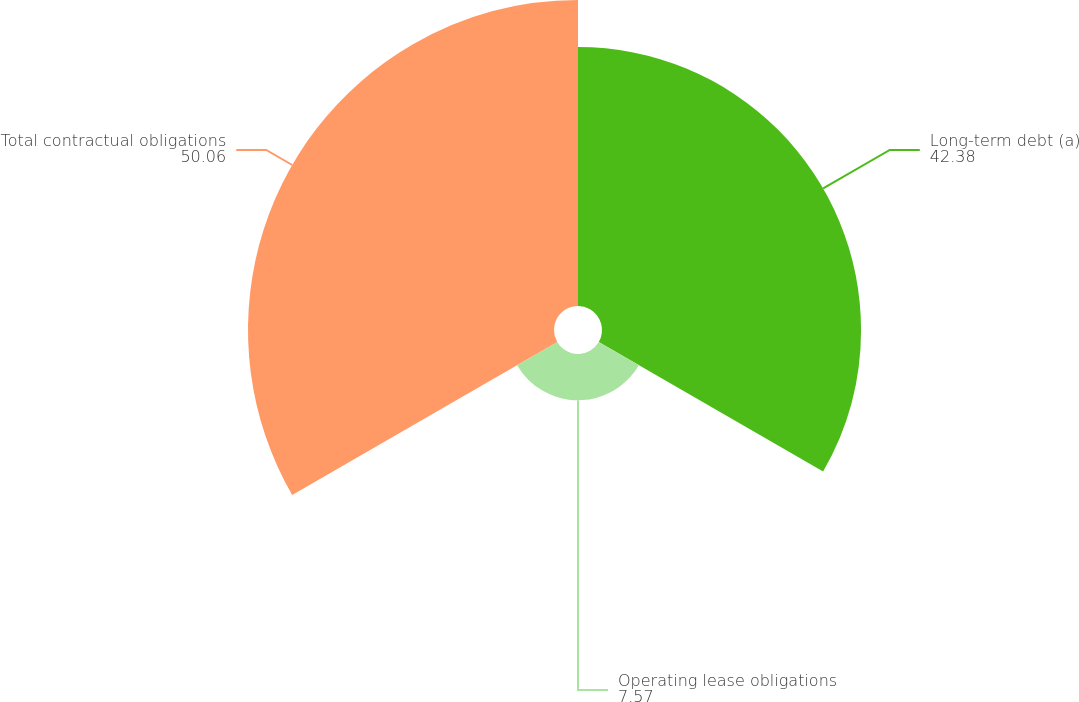<chart> <loc_0><loc_0><loc_500><loc_500><pie_chart><fcel>Long-term debt (a)<fcel>Operating lease obligations<fcel>Total contractual obligations<nl><fcel>42.38%<fcel>7.57%<fcel>50.06%<nl></chart> 